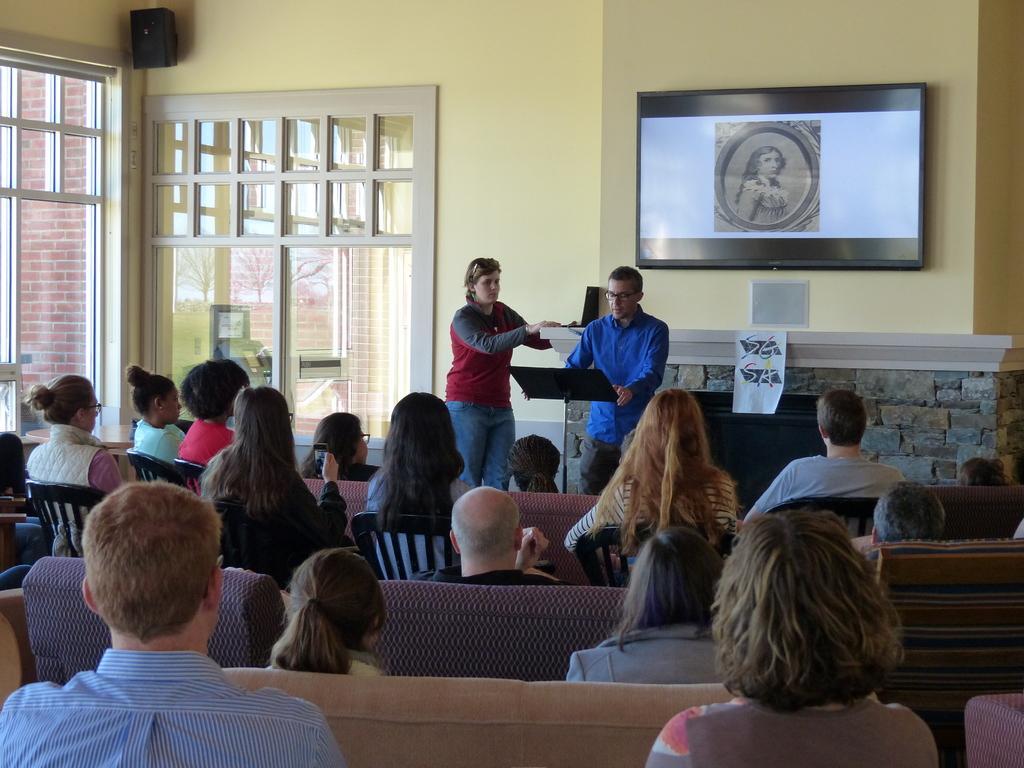Describe this image in one or two sentences. In this image we can see many people sitting. Some are sitting on chairs. Some are sitting on sofas. In the back there are two persons standing. In front of him there is a stand. In the back there is a wall. On the wall there is a screen. Also there is a speaker. Also there are windows. 